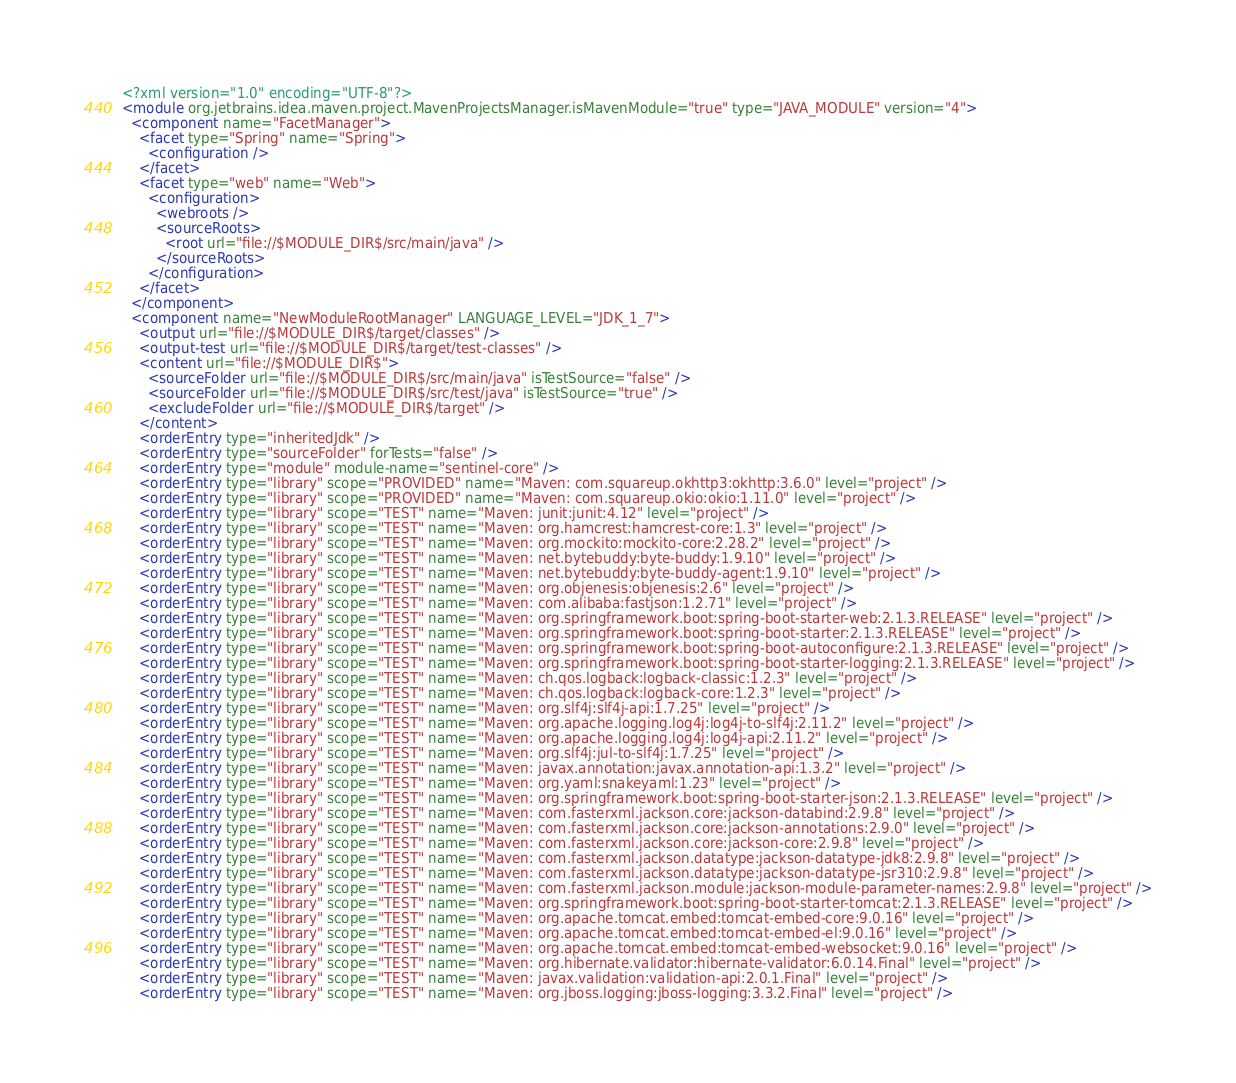<code> <loc_0><loc_0><loc_500><loc_500><_XML_><?xml version="1.0" encoding="UTF-8"?>
<module org.jetbrains.idea.maven.project.MavenProjectsManager.isMavenModule="true" type="JAVA_MODULE" version="4">
  <component name="FacetManager">
    <facet type="Spring" name="Spring">
      <configuration />
    </facet>
    <facet type="web" name="Web">
      <configuration>
        <webroots />
        <sourceRoots>
          <root url="file://$MODULE_DIR$/src/main/java" />
        </sourceRoots>
      </configuration>
    </facet>
  </component>
  <component name="NewModuleRootManager" LANGUAGE_LEVEL="JDK_1_7">
    <output url="file://$MODULE_DIR$/target/classes" />
    <output-test url="file://$MODULE_DIR$/target/test-classes" />
    <content url="file://$MODULE_DIR$">
      <sourceFolder url="file://$MODULE_DIR$/src/main/java" isTestSource="false" />
      <sourceFolder url="file://$MODULE_DIR$/src/test/java" isTestSource="true" />
      <excludeFolder url="file://$MODULE_DIR$/target" />
    </content>
    <orderEntry type="inheritedJdk" />
    <orderEntry type="sourceFolder" forTests="false" />
    <orderEntry type="module" module-name="sentinel-core" />
    <orderEntry type="library" scope="PROVIDED" name="Maven: com.squareup.okhttp3:okhttp:3.6.0" level="project" />
    <orderEntry type="library" scope="PROVIDED" name="Maven: com.squareup.okio:okio:1.11.0" level="project" />
    <orderEntry type="library" scope="TEST" name="Maven: junit:junit:4.12" level="project" />
    <orderEntry type="library" scope="TEST" name="Maven: org.hamcrest:hamcrest-core:1.3" level="project" />
    <orderEntry type="library" scope="TEST" name="Maven: org.mockito:mockito-core:2.28.2" level="project" />
    <orderEntry type="library" scope="TEST" name="Maven: net.bytebuddy:byte-buddy:1.9.10" level="project" />
    <orderEntry type="library" scope="TEST" name="Maven: net.bytebuddy:byte-buddy-agent:1.9.10" level="project" />
    <orderEntry type="library" scope="TEST" name="Maven: org.objenesis:objenesis:2.6" level="project" />
    <orderEntry type="library" scope="TEST" name="Maven: com.alibaba:fastjson:1.2.71" level="project" />
    <orderEntry type="library" scope="TEST" name="Maven: org.springframework.boot:spring-boot-starter-web:2.1.3.RELEASE" level="project" />
    <orderEntry type="library" scope="TEST" name="Maven: org.springframework.boot:spring-boot-starter:2.1.3.RELEASE" level="project" />
    <orderEntry type="library" scope="TEST" name="Maven: org.springframework.boot:spring-boot-autoconfigure:2.1.3.RELEASE" level="project" />
    <orderEntry type="library" scope="TEST" name="Maven: org.springframework.boot:spring-boot-starter-logging:2.1.3.RELEASE" level="project" />
    <orderEntry type="library" scope="TEST" name="Maven: ch.qos.logback:logback-classic:1.2.3" level="project" />
    <orderEntry type="library" scope="TEST" name="Maven: ch.qos.logback:logback-core:1.2.3" level="project" />
    <orderEntry type="library" scope="TEST" name="Maven: org.slf4j:slf4j-api:1.7.25" level="project" />
    <orderEntry type="library" scope="TEST" name="Maven: org.apache.logging.log4j:log4j-to-slf4j:2.11.2" level="project" />
    <orderEntry type="library" scope="TEST" name="Maven: org.apache.logging.log4j:log4j-api:2.11.2" level="project" />
    <orderEntry type="library" scope="TEST" name="Maven: org.slf4j:jul-to-slf4j:1.7.25" level="project" />
    <orderEntry type="library" scope="TEST" name="Maven: javax.annotation:javax.annotation-api:1.3.2" level="project" />
    <orderEntry type="library" scope="TEST" name="Maven: org.yaml:snakeyaml:1.23" level="project" />
    <orderEntry type="library" scope="TEST" name="Maven: org.springframework.boot:spring-boot-starter-json:2.1.3.RELEASE" level="project" />
    <orderEntry type="library" scope="TEST" name="Maven: com.fasterxml.jackson.core:jackson-databind:2.9.8" level="project" />
    <orderEntry type="library" scope="TEST" name="Maven: com.fasterxml.jackson.core:jackson-annotations:2.9.0" level="project" />
    <orderEntry type="library" scope="TEST" name="Maven: com.fasterxml.jackson.core:jackson-core:2.9.8" level="project" />
    <orderEntry type="library" scope="TEST" name="Maven: com.fasterxml.jackson.datatype:jackson-datatype-jdk8:2.9.8" level="project" />
    <orderEntry type="library" scope="TEST" name="Maven: com.fasterxml.jackson.datatype:jackson-datatype-jsr310:2.9.8" level="project" />
    <orderEntry type="library" scope="TEST" name="Maven: com.fasterxml.jackson.module:jackson-module-parameter-names:2.9.8" level="project" />
    <orderEntry type="library" scope="TEST" name="Maven: org.springframework.boot:spring-boot-starter-tomcat:2.1.3.RELEASE" level="project" />
    <orderEntry type="library" scope="TEST" name="Maven: org.apache.tomcat.embed:tomcat-embed-core:9.0.16" level="project" />
    <orderEntry type="library" scope="TEST" name="Maven: org.apache.tomcat.embed:tomcat-embed-el:9.0.16" level="project" />
    <orderEntry type="library" scope="TEST" name="Maven: org.apache.tomcat.embed:tomcat-embed-websocket:9.0.16" level="project" />
    <orderEntry type="library" scope="TEST" name="Maven: org.hibernate.validator:hibernate-validator:6.0.14.Final" level="project" />
    <orderEntry type="library" scope="TEST" name="Maven: javax.validation:validation-api:2.0.1.Final" level="project" />
    <orderEntry type="library" scope="TEST" name="Maven: org.jboss.logging:jboss-logging:3.3.2.Final" level="project" /></code> 